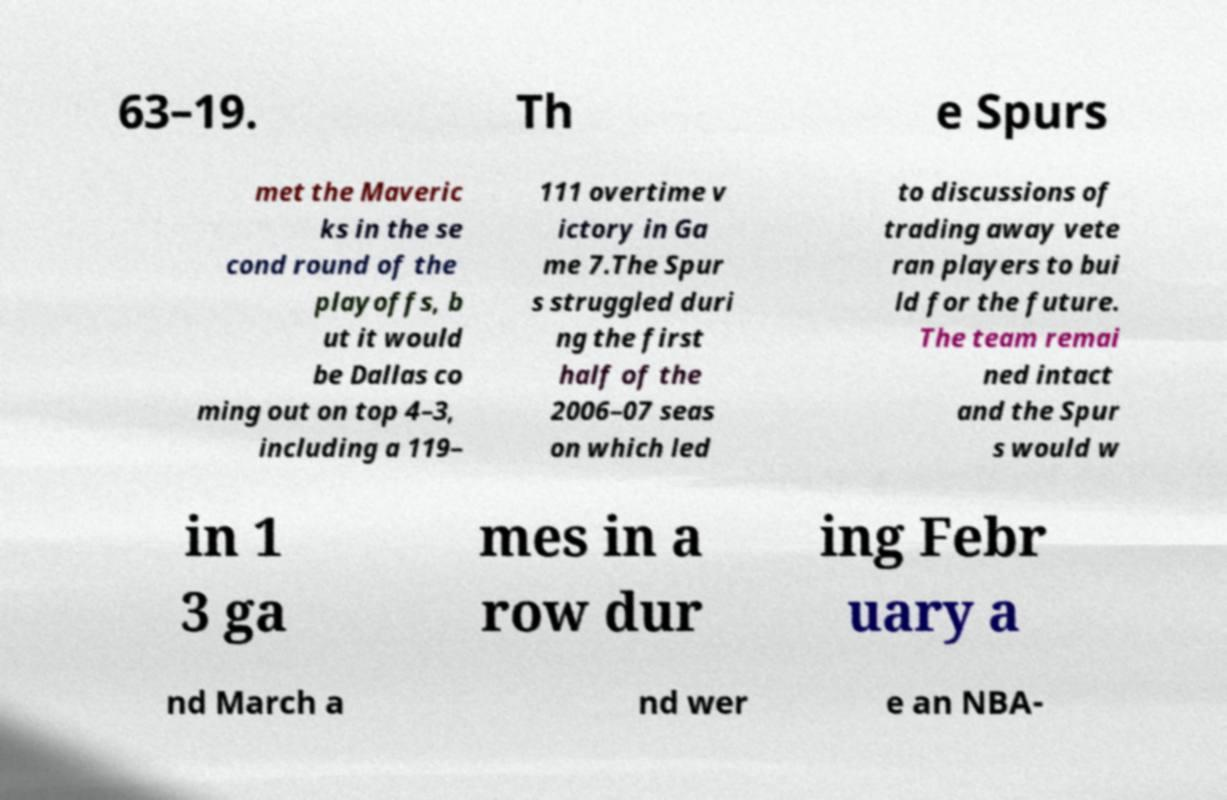Please identify and transcribe the text found in this image. 63–19. Th e Spurs met the Maveric ks in the se cond round of the playoffs, b ut it would be Dallas co ming out on top 4–3, including a 119– 111 overtime v ictory in Ga me 7.The Spur s struggled duri ng the first half of the 2006–07 seas on which led to discussions of trading away vete ran players to bui ld for the future. The team remai ned intact and the Spur s would w in 1 3 ga mes in a row dur ing Febr uary a nd March a nd wer e an NBA- 